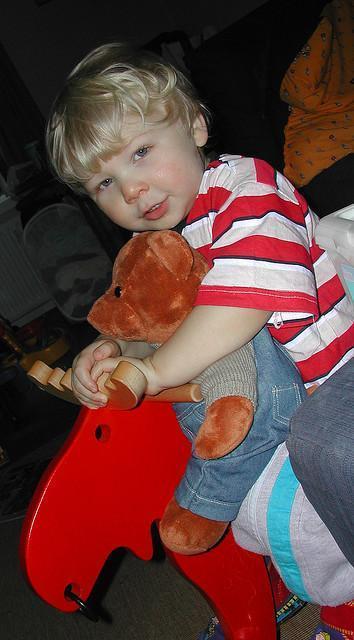How many orange fruit are there?
Give a very brief answer. 0. 